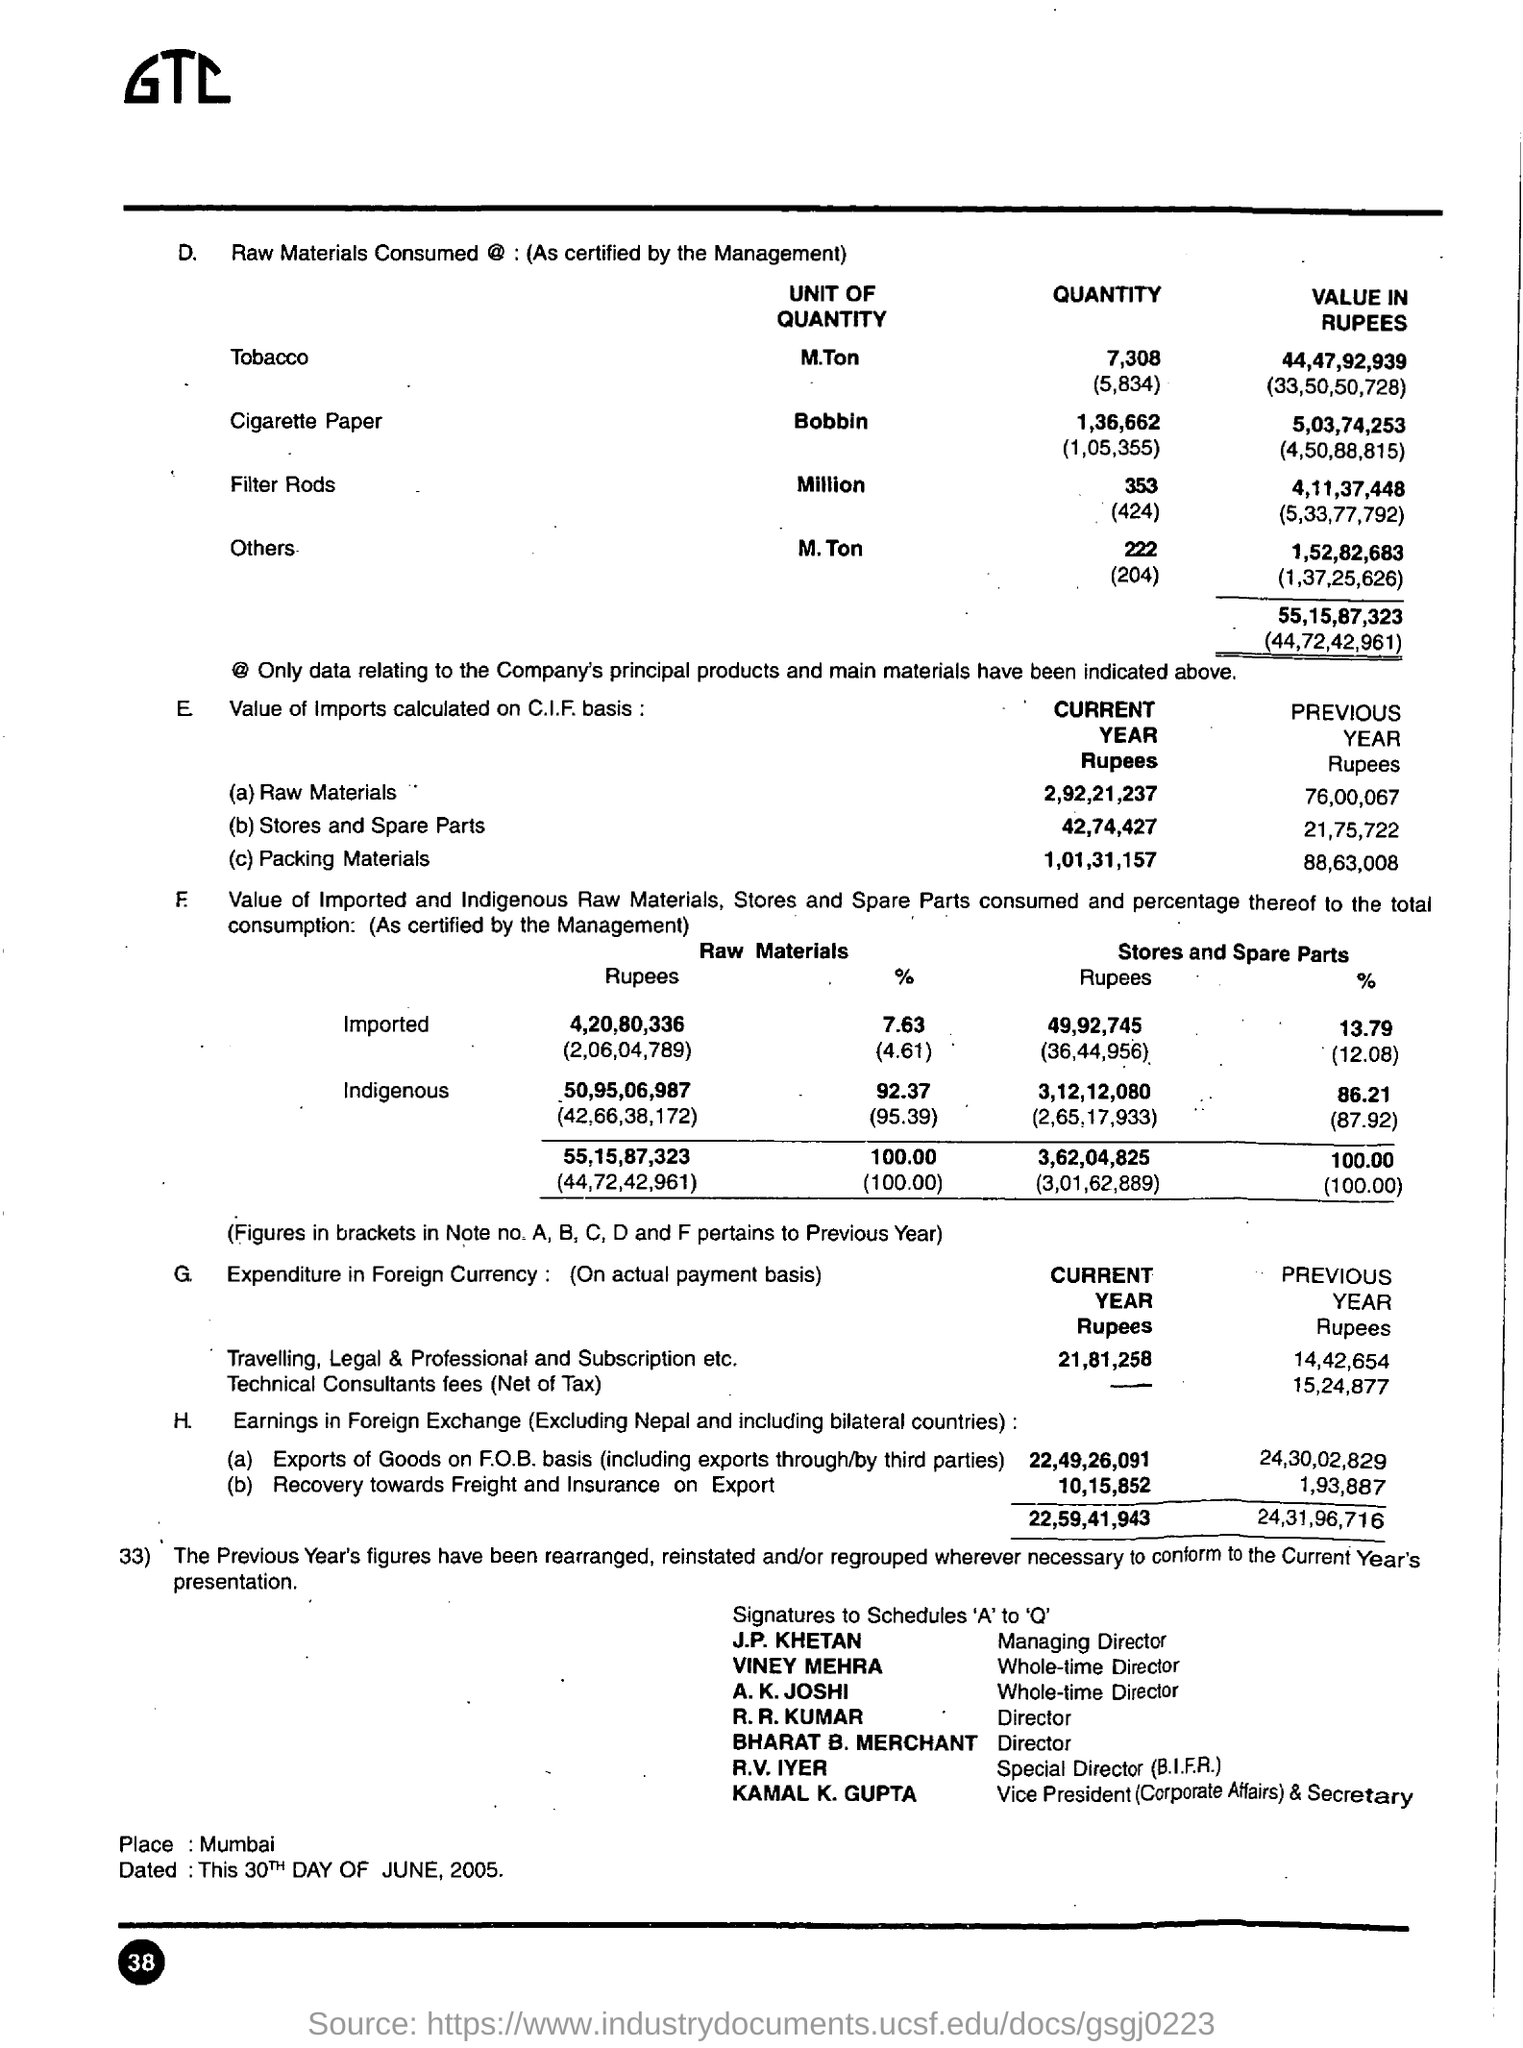What is the place mentioned in the document?
Your response must be concise. Mumbai. 